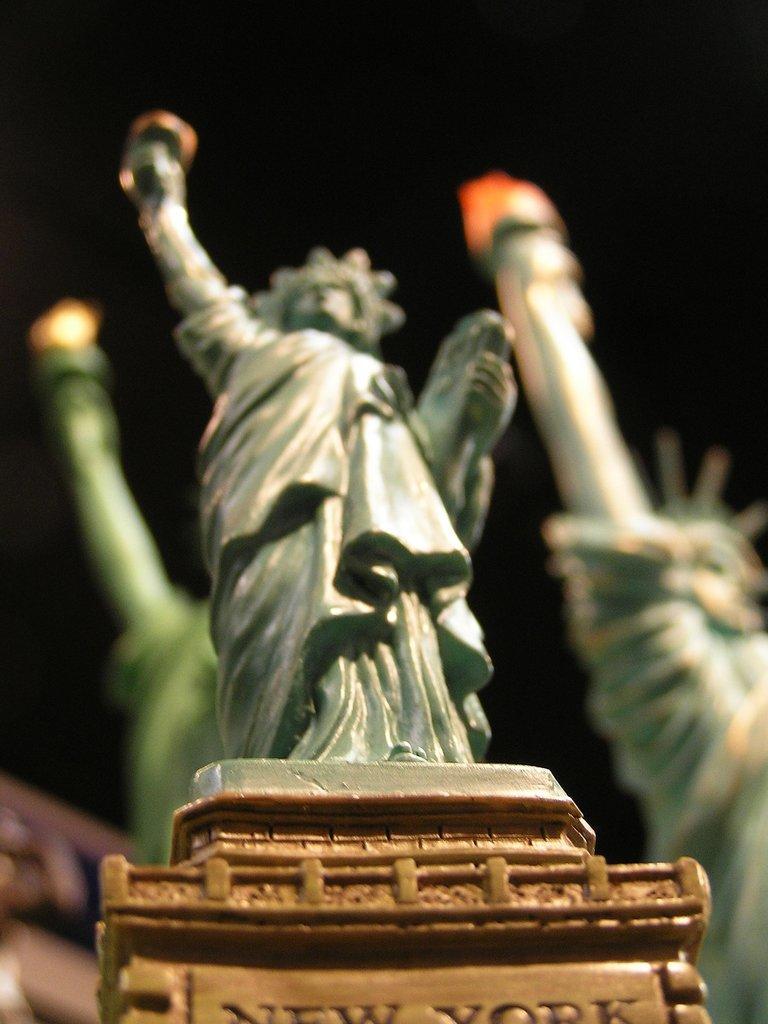Describe this image in one or two sentences. In front of the image there is a statue on the pedestal. Behind that statue there are two more statues and there is a blur background. 